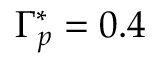<formula> <loc_0><loc_0><loc_500><loc_500>\Gamma _ { p } ^ { * } = 0 . 4</formula> 